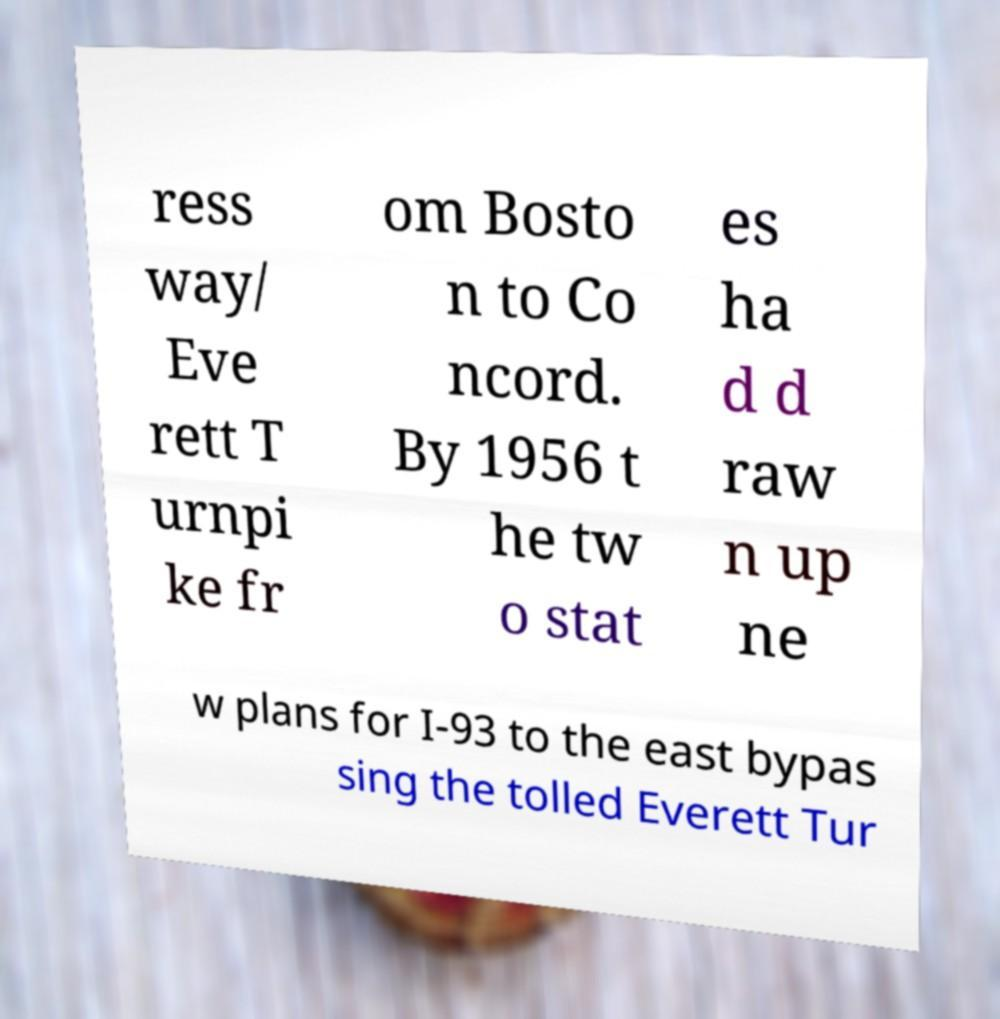There's text embedded in this image that I need extracted. Can you transcribe it verbatim? ress way/ Eve rett T urnpi ke fr om Bosto n to Co ncord. By 1956 t he tw o stat es ha d d raw n up ne w plans for I-93 to the east bypas sing the tolled Everett Tur 